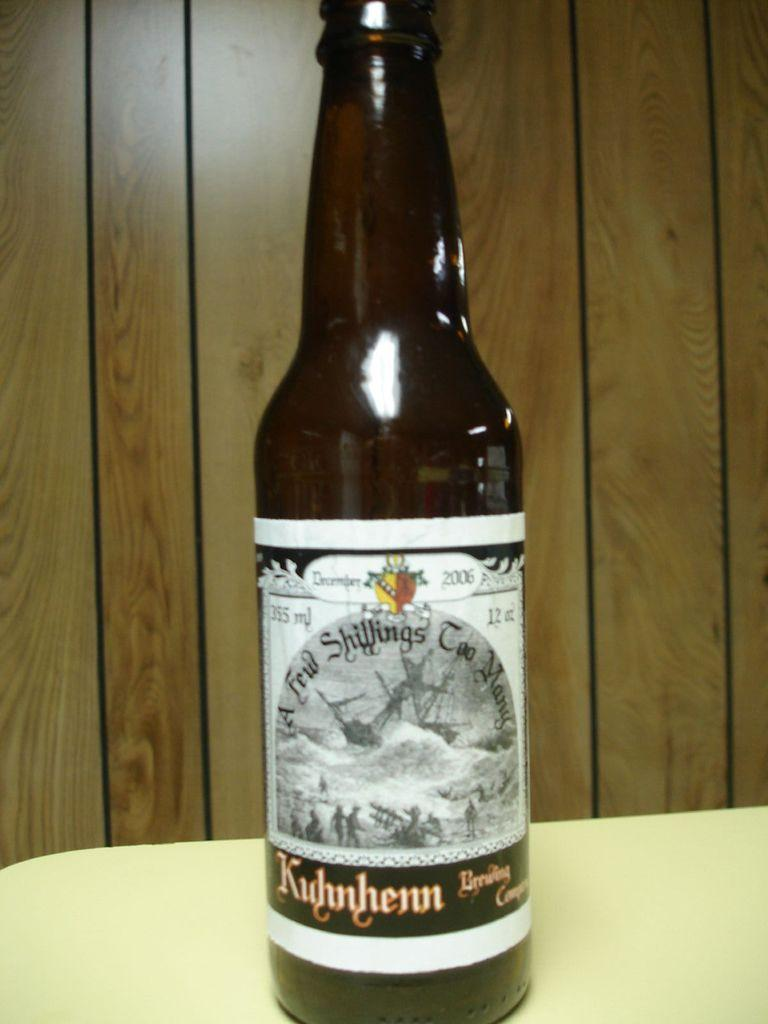<image>
Create a compact narrative representing the image presented. A bottle of beer from the Kidhnhenn Brewing Company. 